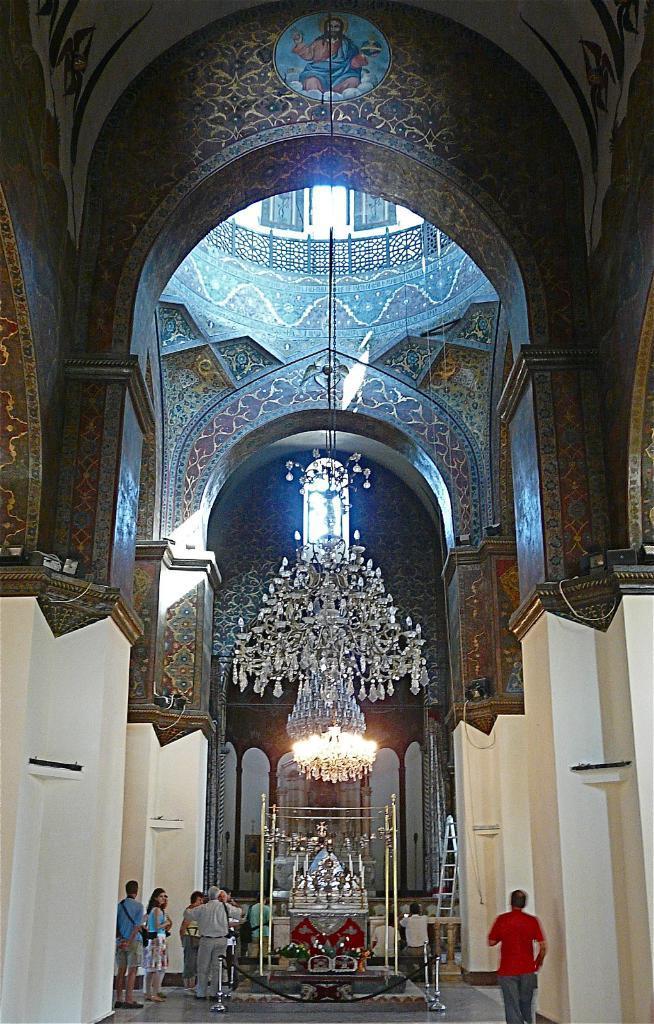How would you summarize this image in a sentence or two? A picture inside of a building. Here we can see chandelier, people and ladder. 